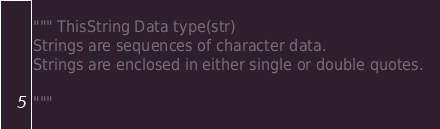<code> <loc_0><loc_0><loc_500><loc_500><_Python_>""" ThisString Data type(str)
Strings are sequences of character data.
Strings are enclosed in either single or double quotes.

"""</code> 